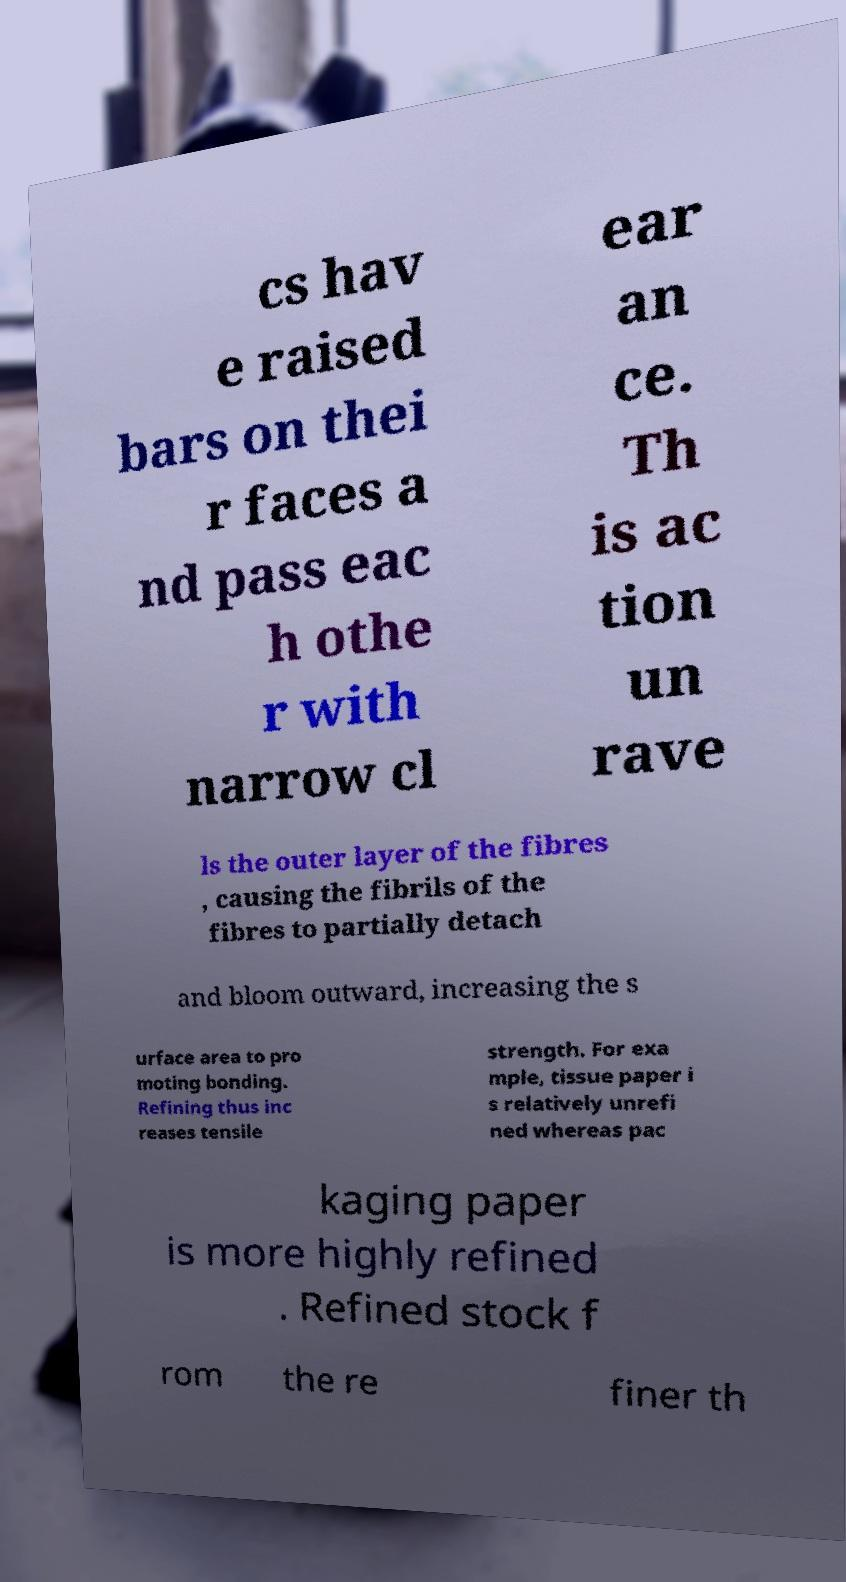Please identify and transcribe the text found in this image. cs hav e raised bars on thei r faces a nd pass eac h othe r with narrow cl ear an ce. Th is ac tion un rave ls the outer layer of the fibres , causing the fibrils of the fibres to partially detach and bloom outward, increasing the s urface area to pro moting bonding. Refining thus inc reases tensile strength. For exa mple, tissue paper i s relatively unrefi ned whereas pac kaging paper is more highly refined . Refined stock f rom the re finer th 